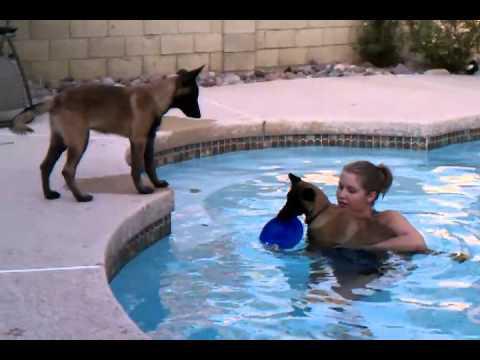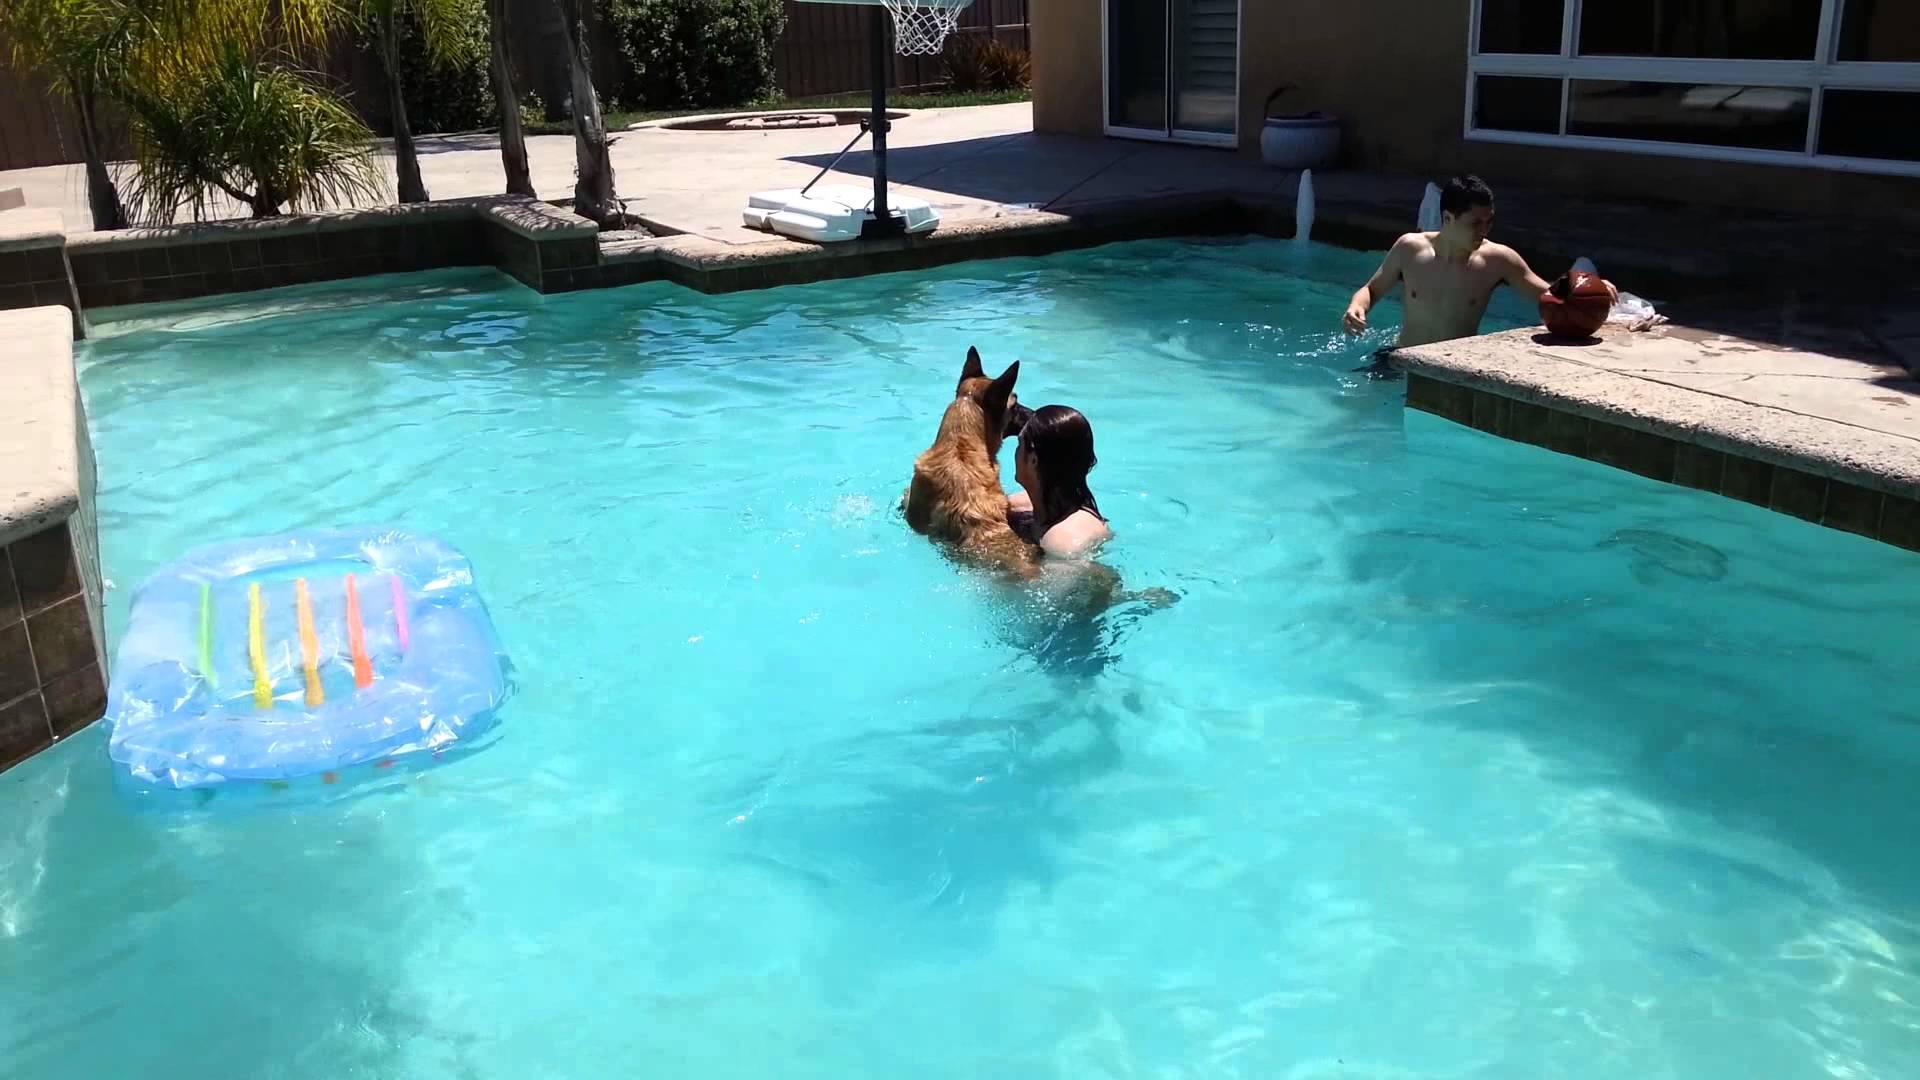The first image is the image on the left, the second image is the image on the right. For the images displayed, is the sentence "Two dogs are in water." factually correct? Answer yes or no. Yes. 